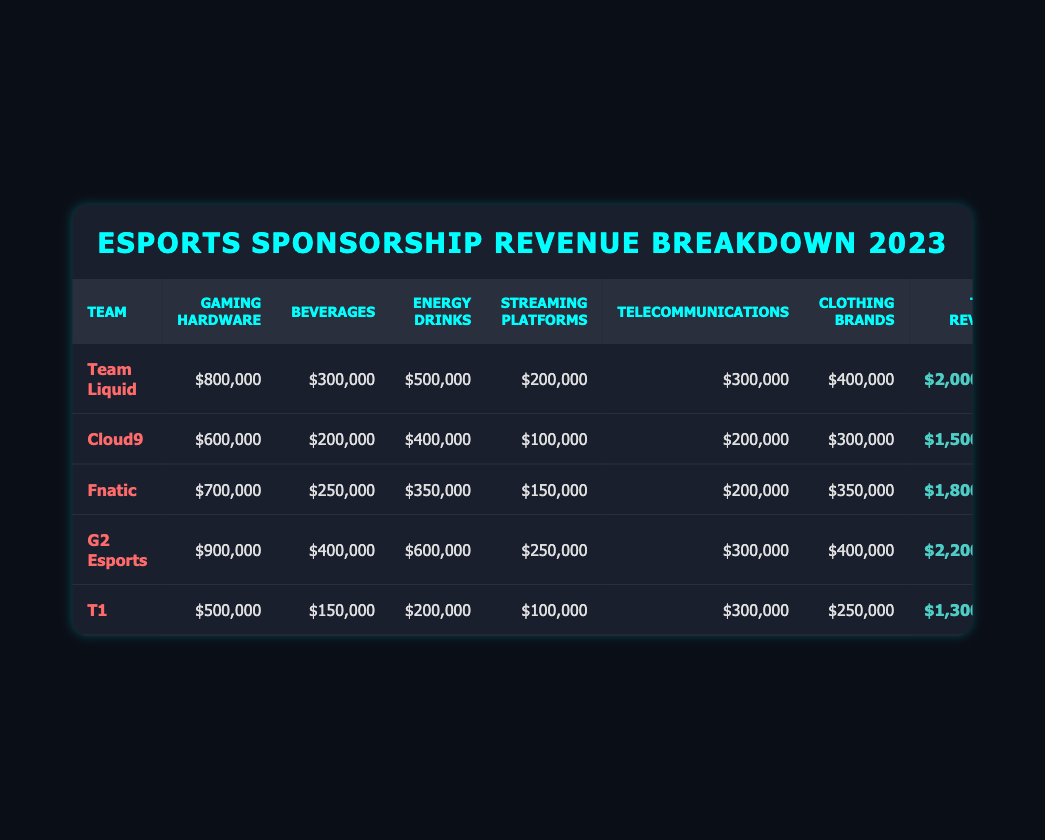What is the total sponsorship revenue for G2 Esports? The total sponsorship revenue for G2 Esports is found in the "Total Revenue" column. According to the table, G2 Esports has a total sponsorship revenue of 2,200,000.
Answer: 2,200,000 Which team received the highest revenue from gaming hardware? We can compare the revenues listed under the "Gaming Hardware" column. G2 Esports has 900,000, followed by Team Liquid with 800,000, Cloud9 with 600,000, and so on. Thus, G2 Esports received the highest revenue from gaming hardware.
Answer: G2 Esports What is the total sponsorship revenue for Fnatic plus T1? To find this total, we must add Fnatic's total sponsorship revenue of 1,800,000 with T1's total of 1,300,000. Adding these values gives us 1,800,000 + 1,300,000 = 3,100,000.
Answer: 3,100,000 Is it true that Team Liquid received more from energy drinks than T1? From the "Energy Drinks" column, Team Liquid received 500,000, whereas T1 received only 200,000. Since 500,000 is greater than 200,000, the statement is true.
Answer: Yes What percentage of G2 Esports' total sponsorship revenue came from beverages? First, we find the revenue from beverages for G2 Esports, which is 400,000. Then, we calculate the percentage by dividing the beverage revenue by the total sponsorship revenue: (400,000 / 2,200,000) * 100. Calculating this gives approximately 18.18%.
Answer: 18.18% Which team has the smallest total sponsorship revenue? To find the smallest total, we compare the total revenues of each team in the "Total Revenue" column. T1 has the lowest total, with 1,300,000.
Answer: T1 What is the total amount of sponsorship revenue from energy drinks across all teams? We need to sum the "Energy Drinks" revenues from each team: Team Liquid (500,000) + Cloud9 (400,000) + Fnatic (350,000) + G2 Esports (600,000) + T1 (200,000). Adding these values gives 500,000 + 400,000 + 350,000 + 600,000 + 200,000 = 2,050,000.
Answer: 2,050,000 Did Team Liquid earn more than 1 million from beverages? Team Liquid's revenue from beverages is 300,000, which is less than 1 million. Therefore, the statement is false.
Answer: No Which team has the second-highest revenue from telecommunications? In the "Telecommunications" column, G2 Esports, Team Liquid, and T1 all received the same amount of 300,000. However, since G2 Esports has the highest total sponsorship revenue, and Team Liquid is next, we conclude that Team Liquid has the second-highest revenue by total sponsorship, not just in telecommunications.
Answer: Team Liquid 